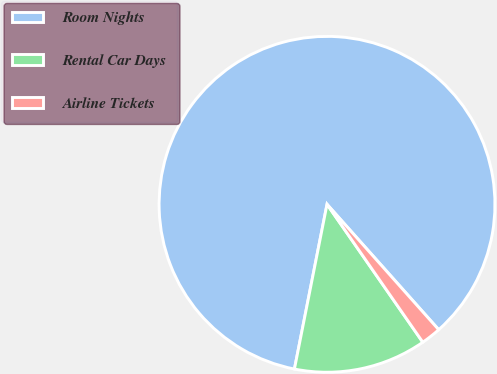Convert chart to OTSL. <chart><loc_0><loc_0><loc_500><loc_500><pie_chart><fcel>Room Nights<fcel>Rental Car Days<fcel>Airline Tickets<nl><fcel>85.31%<fcel>12.77%<fcel>1.92%<nl></chart> 